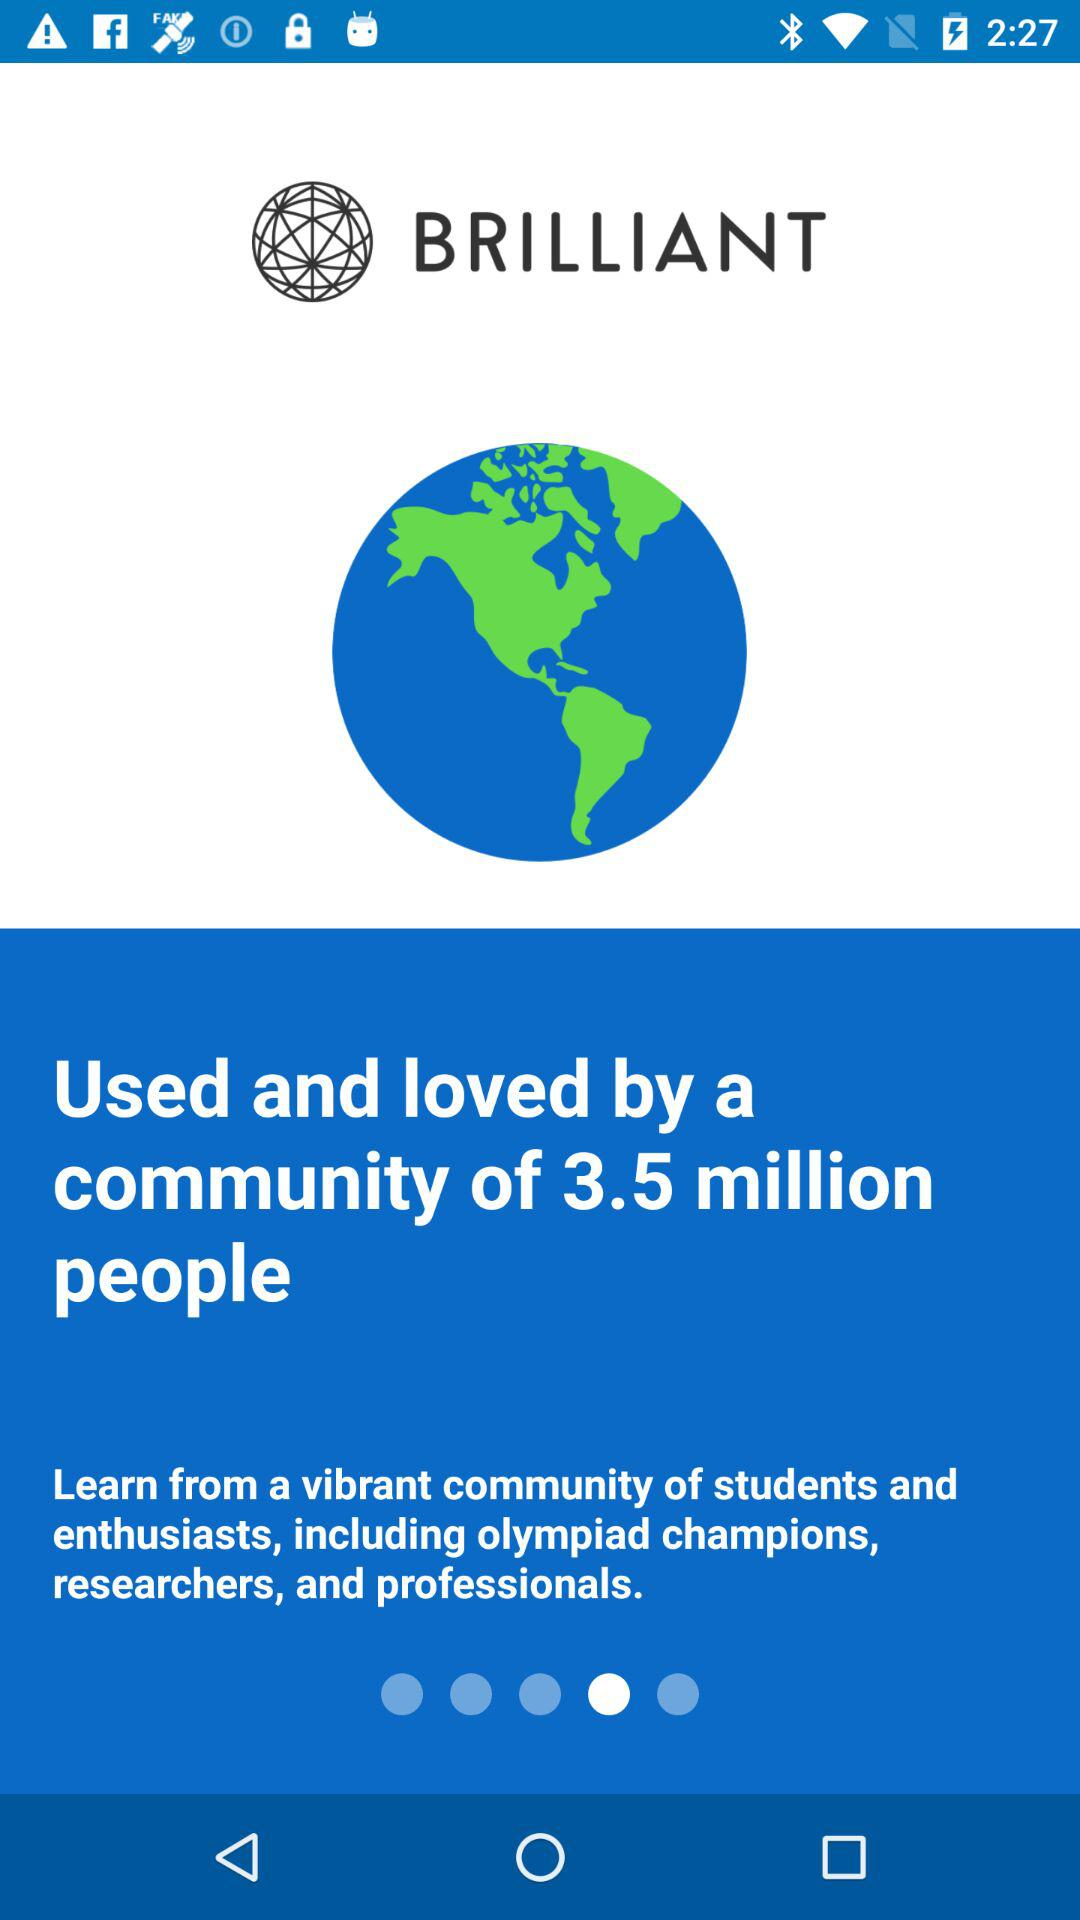How many people loved and used the application? The number of people who loved and used the application is 3.5 million. 